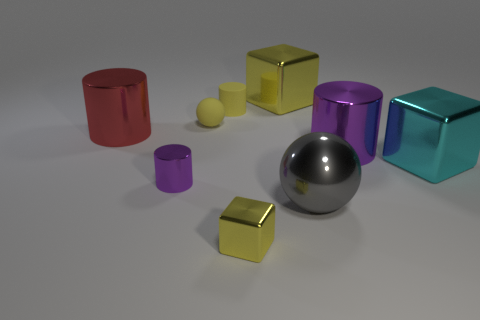Subtract all gray cylinders. Subtract all blue spheres. How many cylinders are left? 4 Add 1 metal cylinders. How many objects exist? 10 Subtract all cylinders. How many objects are left? 5 Subtract all tiny purple things. Subtract all tiny cylinders. How many objects are left? 6 Add 5 tiny purple objects. How many tiny purple objects are left? 6 Add 1 large red spheres. How many large red spheres exist? 1 Subtract 0 purple spheres. How many objects are left? 9 